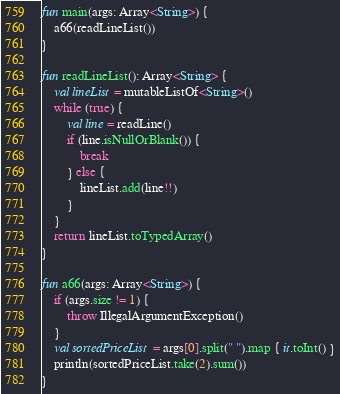<code> <loc_0><loc_0><loc_500><loc_500><_Kotlin_>fun main(args: Array<String>) {
    a66(readLineList())
}

fun readLineList(): Array<String> {
    val lineList = mutableListOf<String>()
    while (true) {
        val line = readLine()
        if (line.isNullOrBlank()) {
            break
        } else {
            lineList.add(line!!)
        }
    }
    return lineList.toTypedArray()
}

fun a66(args: Array<String>) {
    if (args.size != 1) {
        throw IllegalArgumentException()
    }
    val sortedPriceList = args[0].split(" ").map { it.toInt() }
    println(sortedPriceList.take(2).sum())
}</code> 